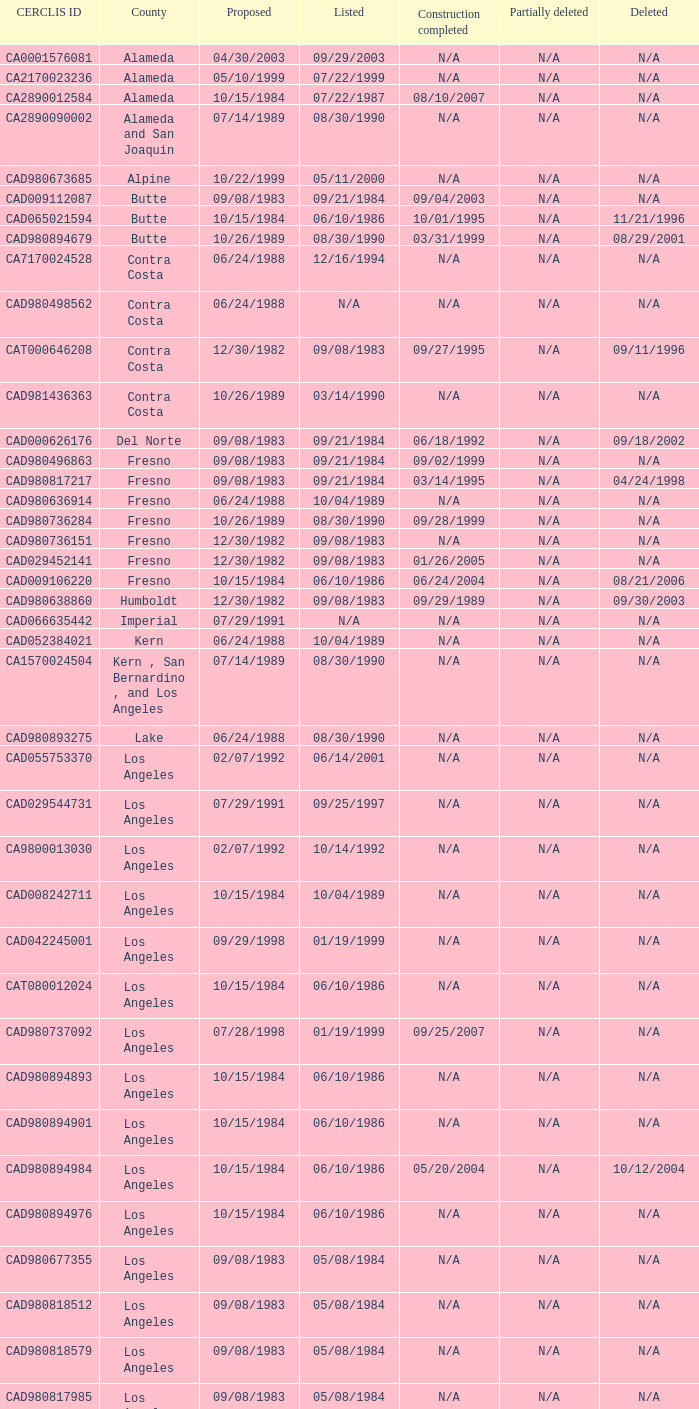Which construction project was finished on august 10, 2007? 07/22/1987. 